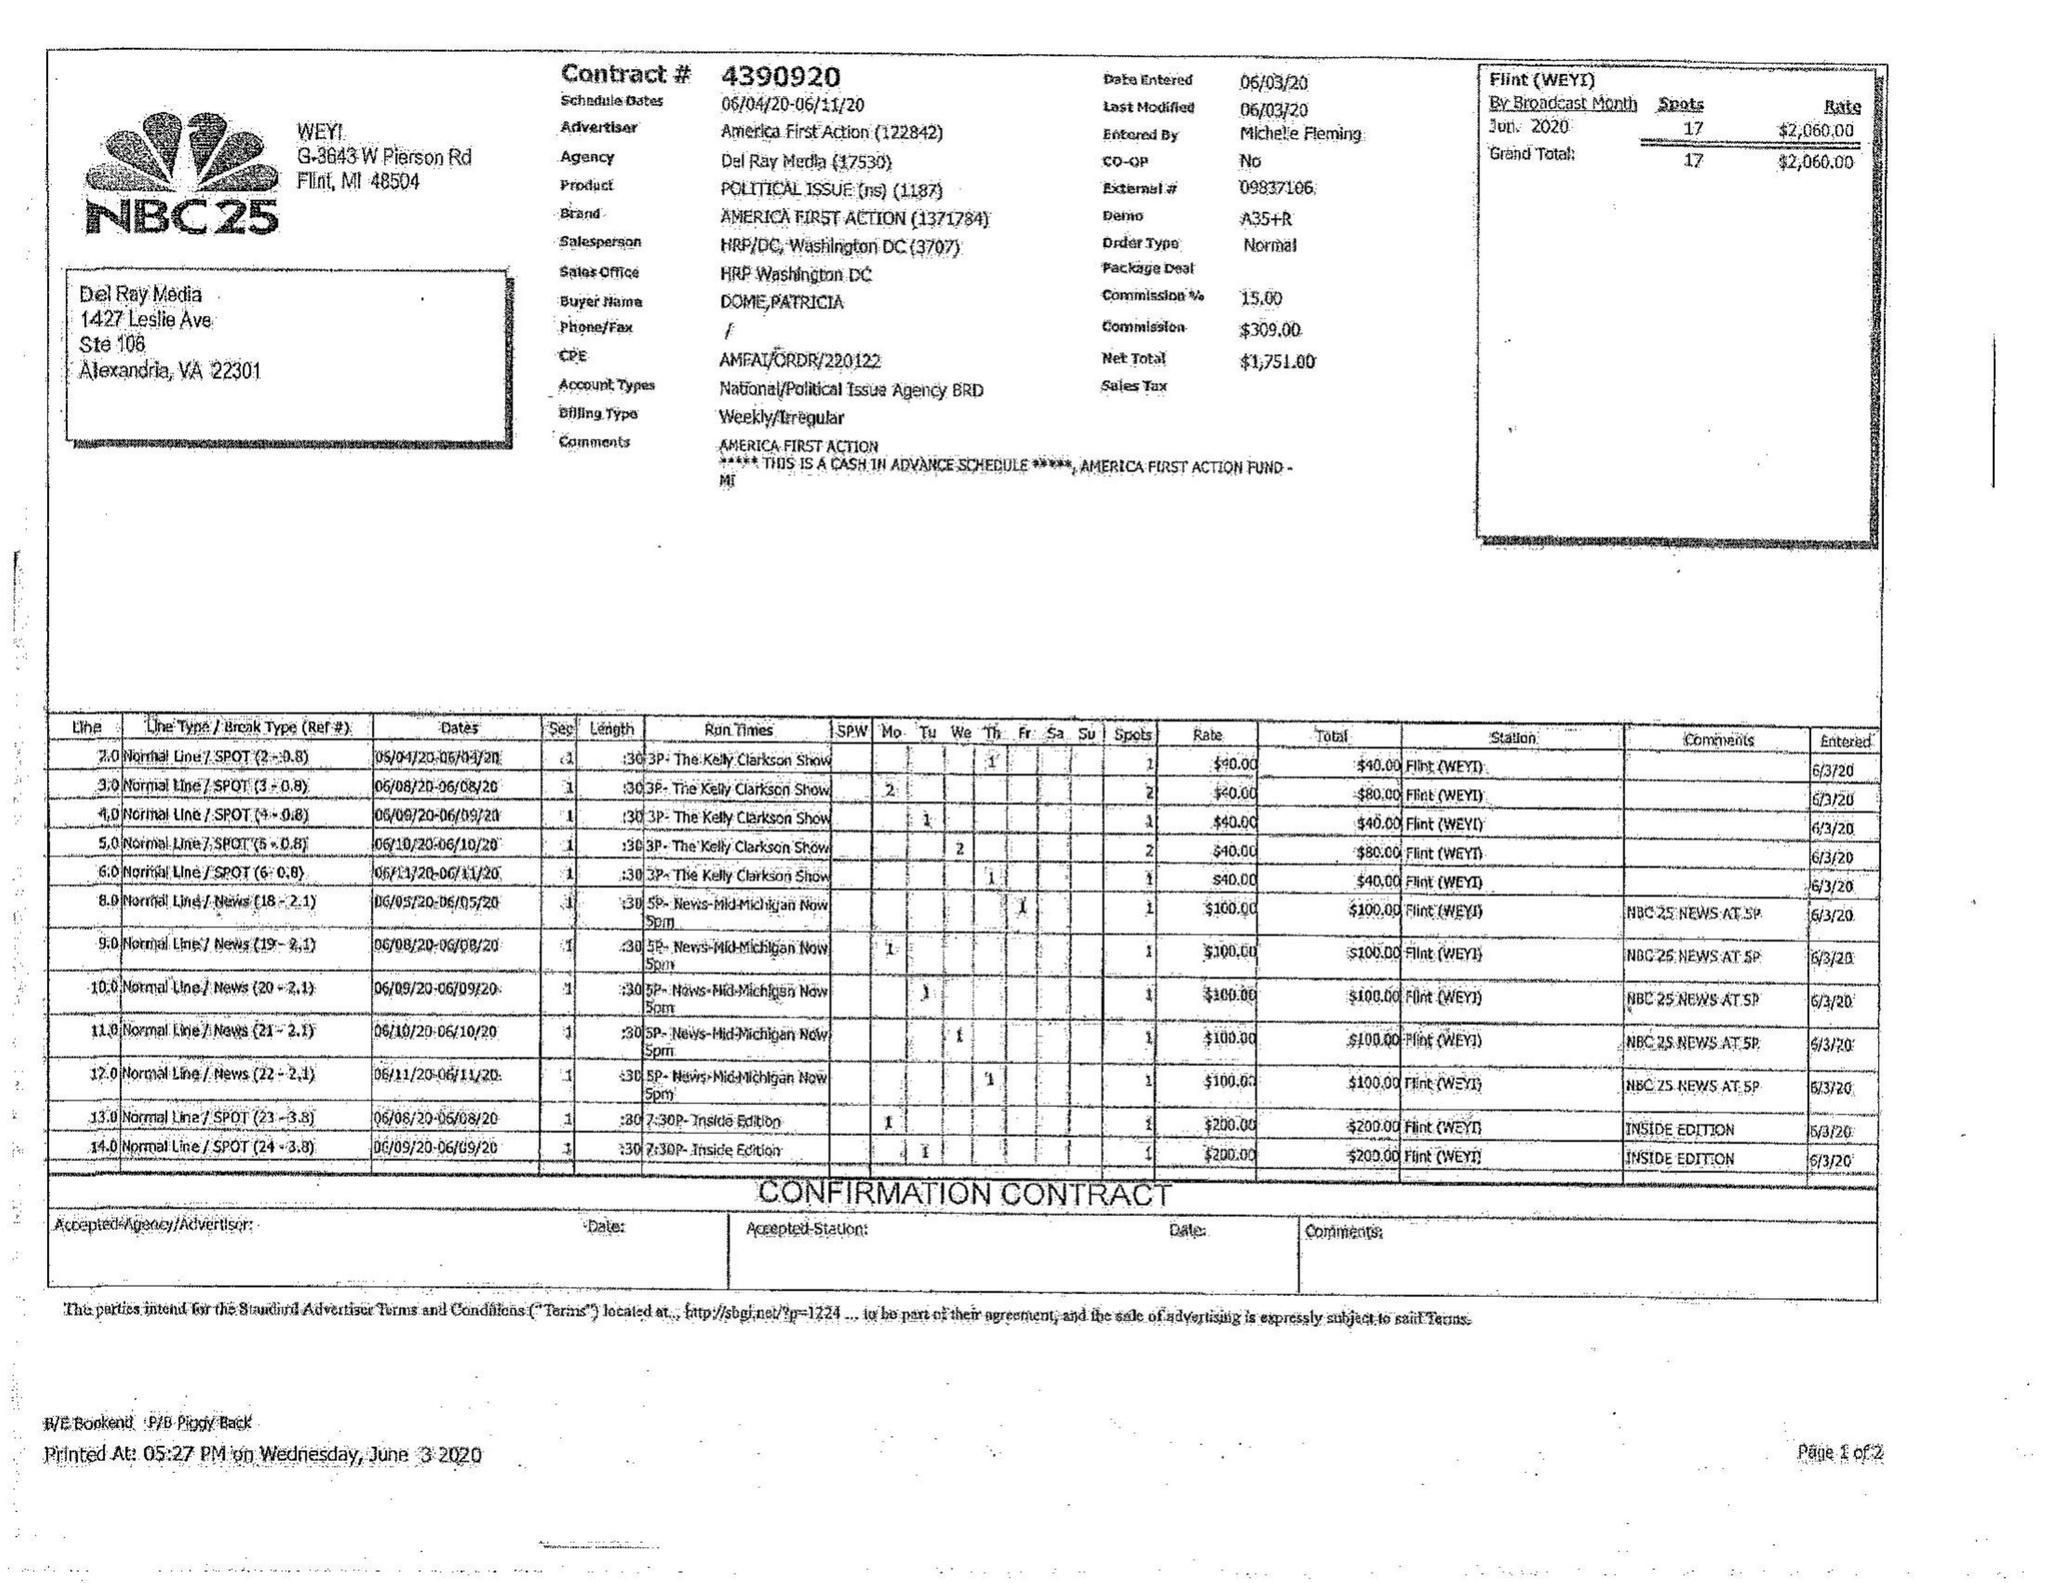What is the value for the gross_amount?
Answer the question using a single word or phrase. 2060.00 